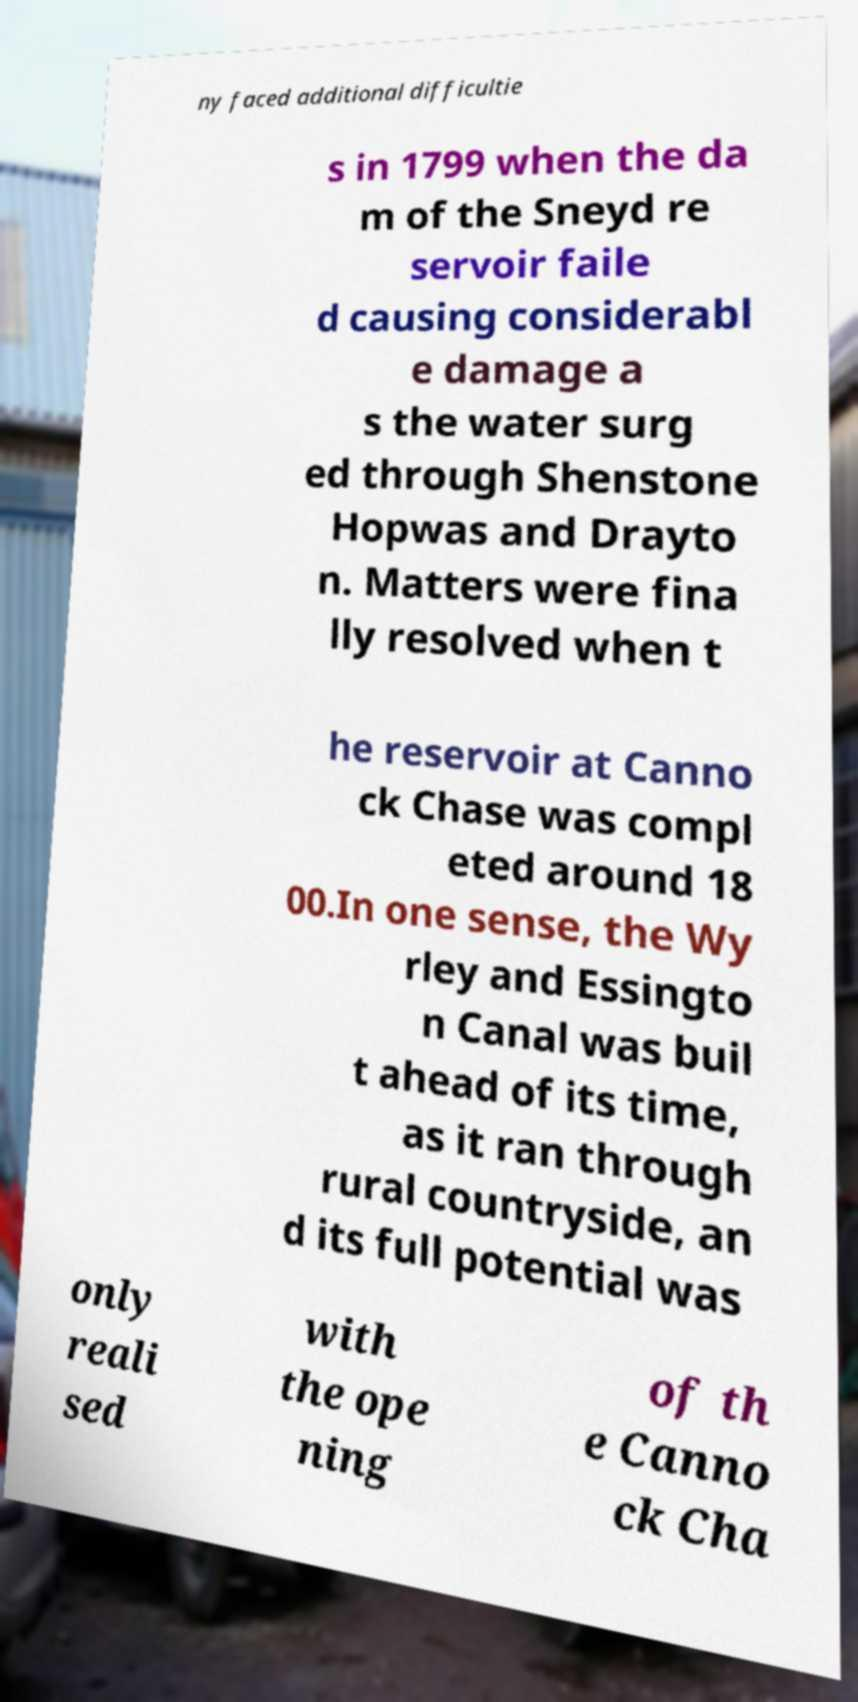Can you accurately transcribe the text from the provided image for me? ny faced additional difficultie s in 1799 when the da m of the Sneyd re servoir faile d causing considerabl e damage a s the water surg ed through Shenstone Hopwas and Drayto n. Matters were fina lly resolved when t he reservoir at Canno ck Chase was compl eted around 18 00.In one sense, the Wy rley and Essingto n Canal was buil t ahead of its time, as it ran through rural countryside, an d its full potential was only reali sed with the ope ning of th e Canno ck Cha 